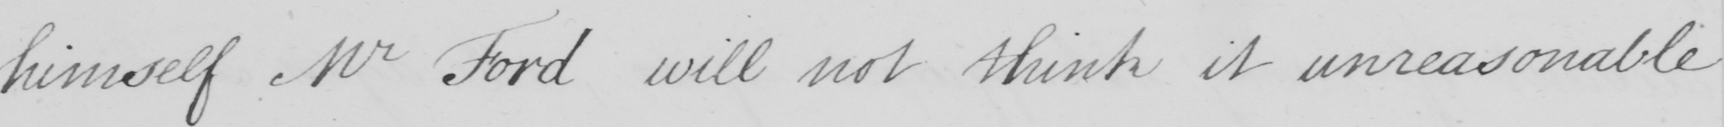Please provide the text content of this handwritten line. himself Mr Ford will not think it unreasonable 